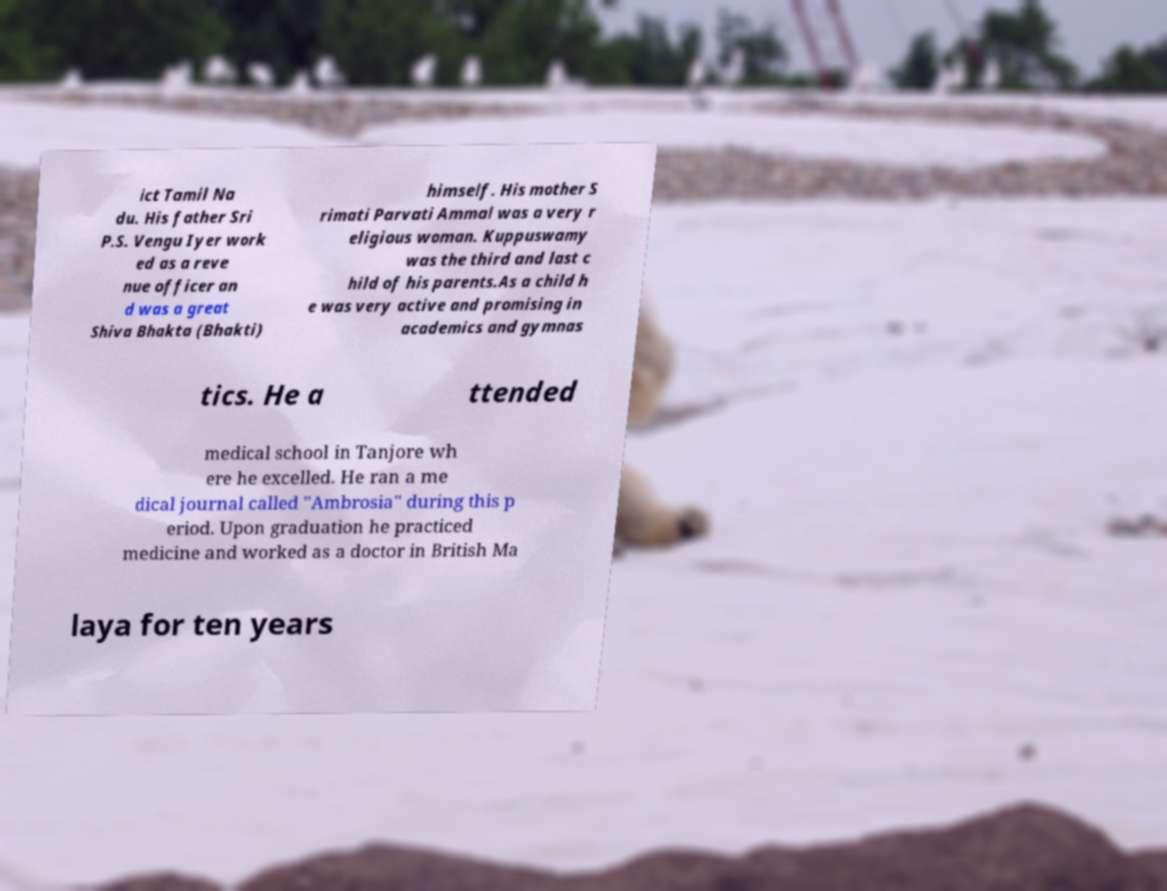What messages or text are displayed in this image? I need them in a readable, typed format. ict Tamil Na du. His father Sri P.S. Vengu Iyer work ed as a reve nue officer an d was a great Shiva Bhakta (Bhakti) himself. His mother S rimati Parvati Ammal was a very r eligious woman. Kuppuswamy was the third and last c hild of his parents.As a child h e was very active and promising in academics and gymnas tics. He a ttended medical school in Tanjore wh ere he excelled. He ran a me dical journal called "Ambrosia" during this p eriod. Upon graduation he practiced medicine and worked as a doctor in British Ma laya for ten years 